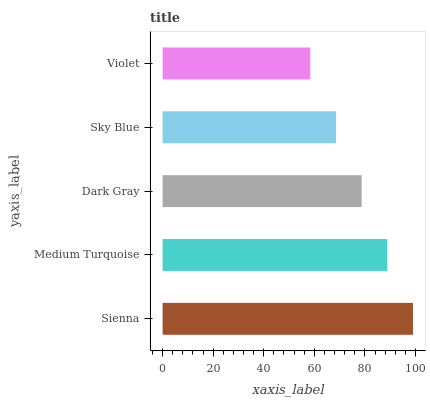Is Violet the minimum?
Answer yes or no. Yes. Is Sienna the maximum?
Answer yes or no. Yes. Is Medium Turquoise the minimum?
Answer yes or no. No. Is Medium Turquoise the maximum?
Answer yes or no. No. Is Sienna greater than Medium Turquoise?
Answer yes or no. Yes. Is Medium Turquoise less than Sienna?
Answer yes or no. Yes. Is Medium Turquoise greater than Sienna?
Answer yes or no. No. Is Sienna less than Medium Turquoise?
Answer yes or no. No. Is Dark Gray the high median?
Answer yes or no. Yes. Is Dark Gray the low median?
Answer yes or no. Yes. Is Sienna the high median?
Answer yes or no. No. Is Sienna the low median?
Answer yes or no. No. 